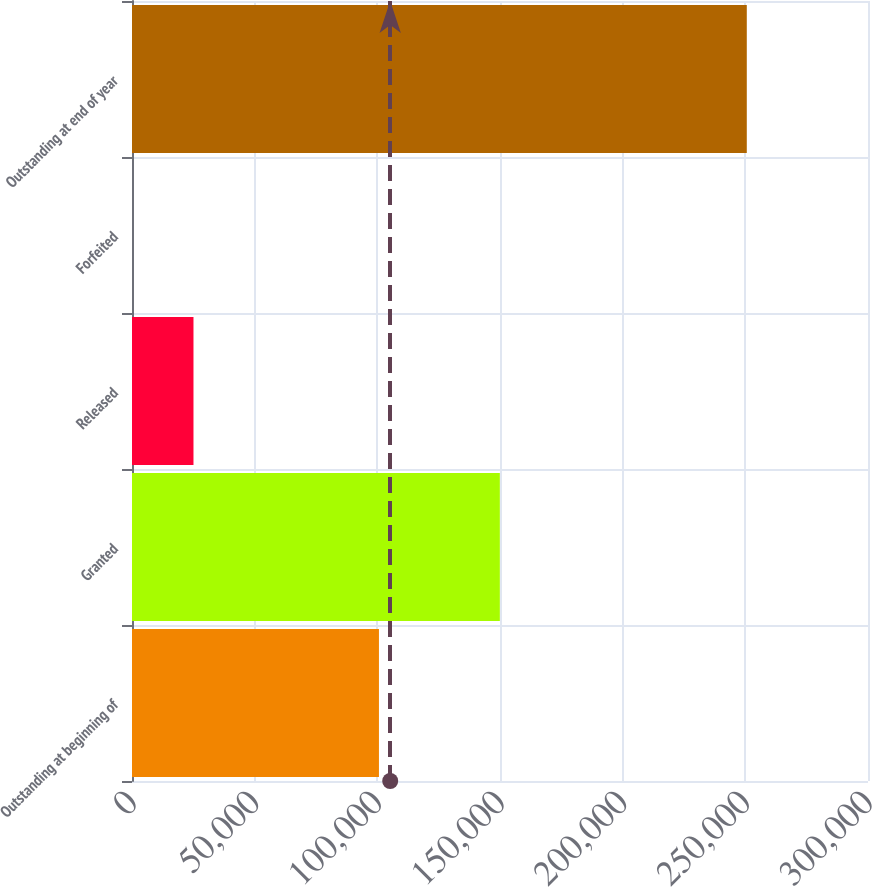<chart> <loc_0><loc_0><loc_500><loc_500><bar_chart><fcel>Outstanding at beginning of<fcel>Granted<fcel>Released<fcel>Forfeited<fcel>Outstanding at end of year<nl><fcel>100660<fcel>149936<fcel>25059.8<fcel>0.21<fcel>250596<nl></chart> 